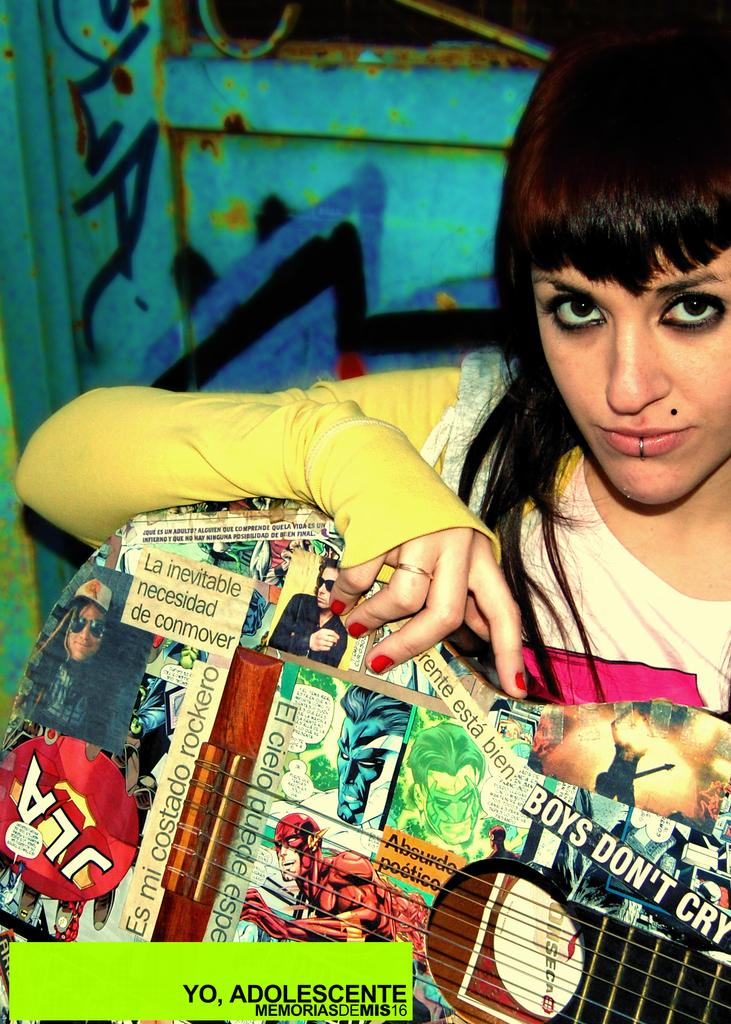<image>
Offer a succinct explanation of the picture presented. A woman has a collage that includes the line "boys don't cry." 